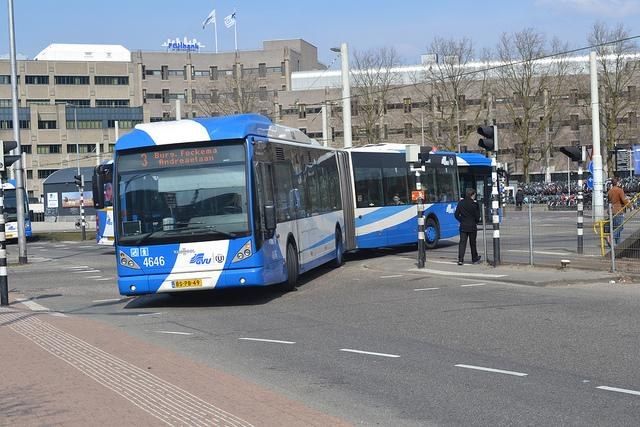What style design connects the two bus parts here? accordion 